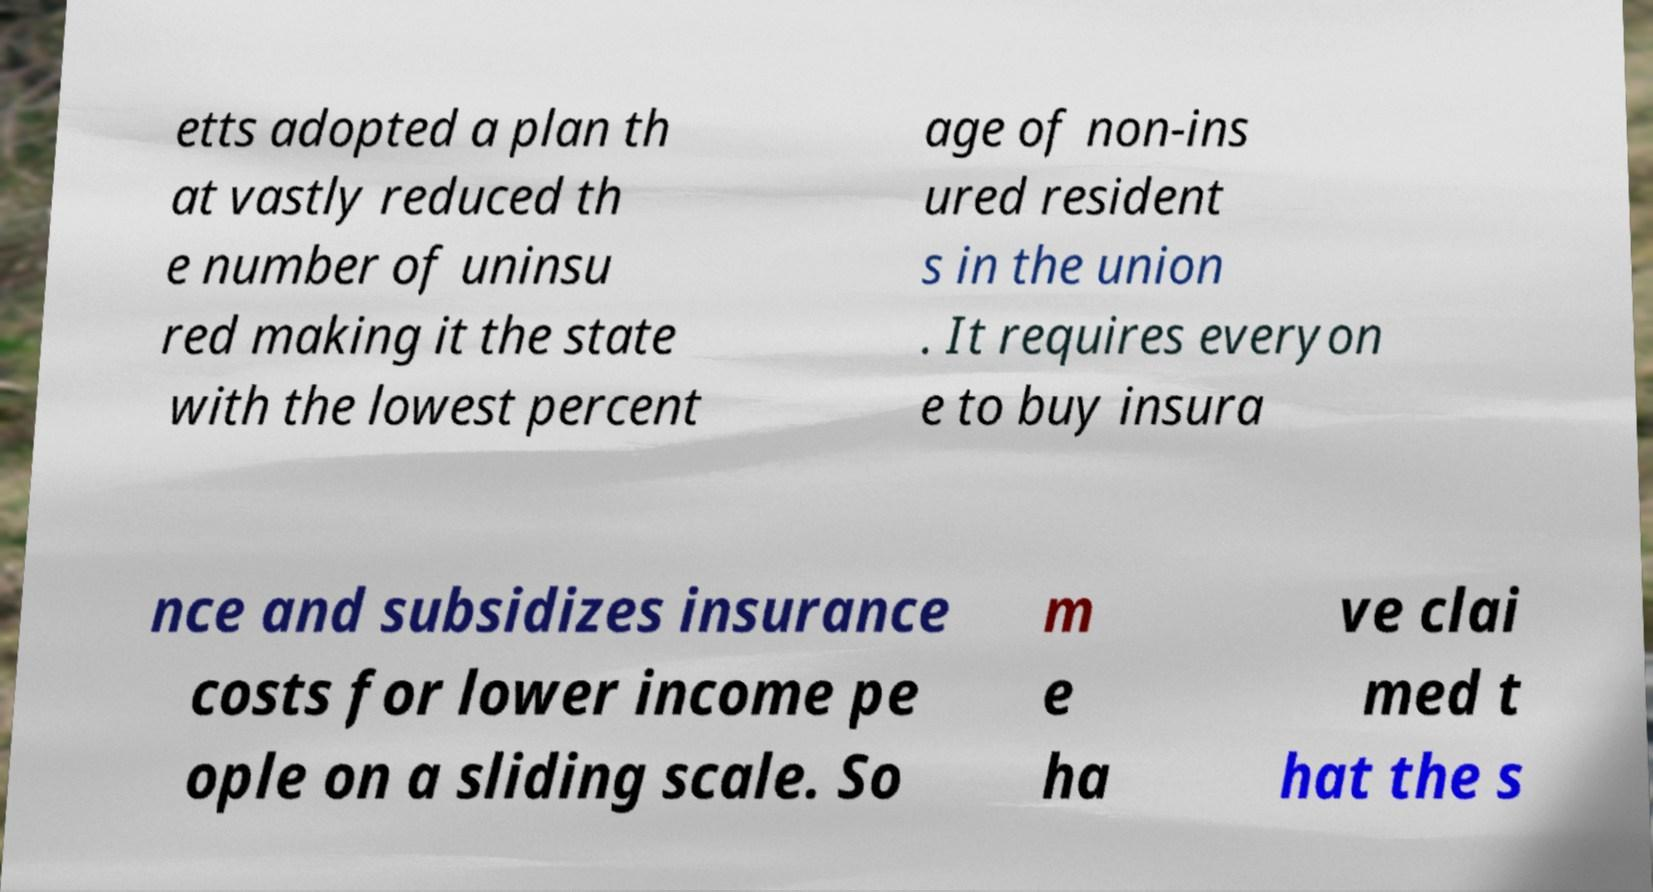Please read and relay the text visible in this image. What does it say? etts adopted a plan th at vastly reduced th e number of uninsu red making it the state with the lowest percent age of non-ins ured resident s in the union . It requires everyon e to buy insura nce and subsidizes insurance costs for lower income pe ople on a sliding scale. So m e ha ve clai med t hat the s 